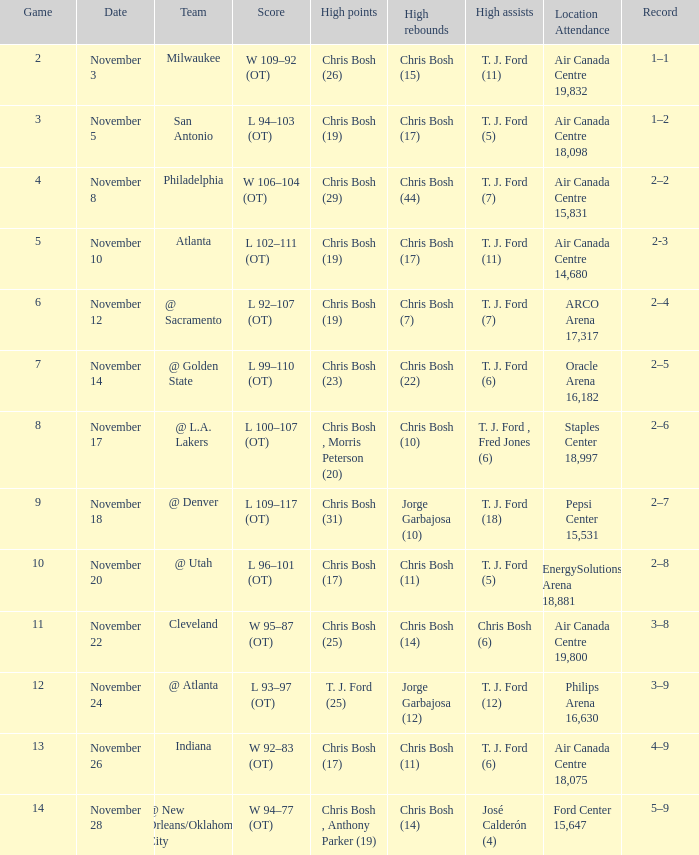Who accumulated the greatest points in game 4? Chris Bosh (29). 